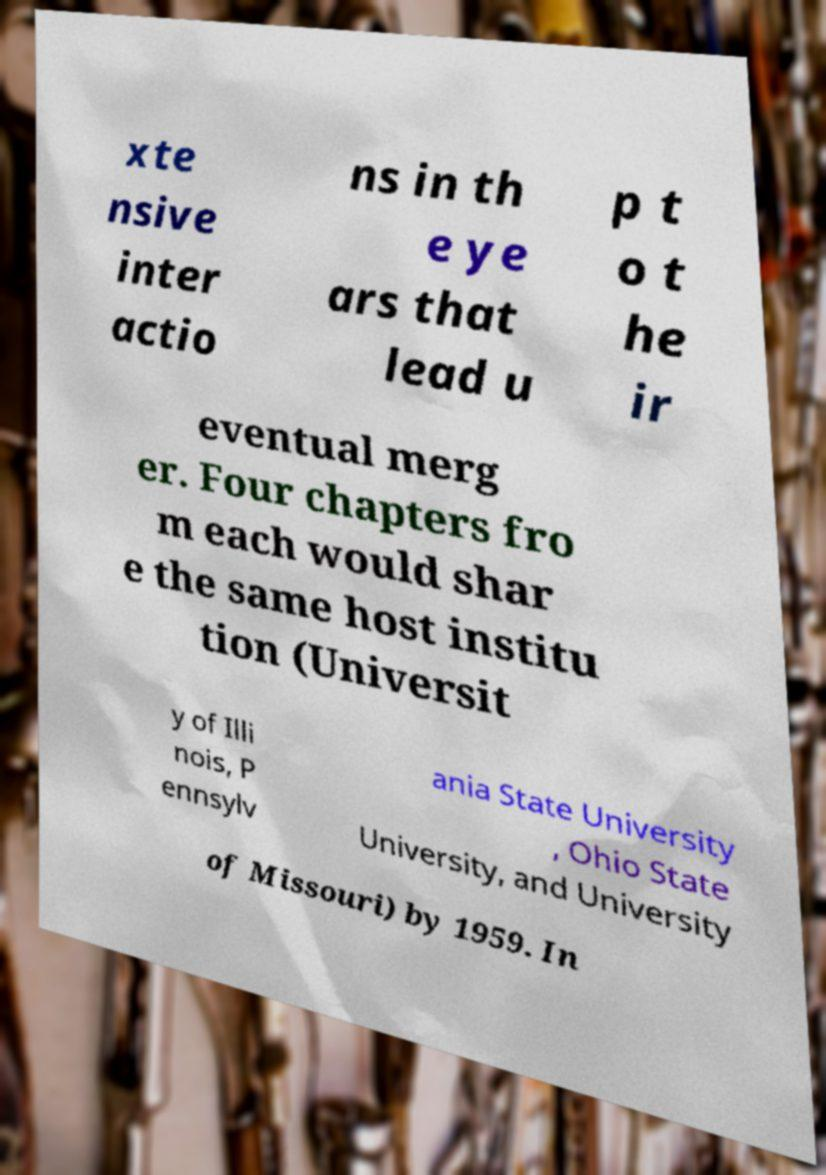For documentation purposes, I need the text within this image transcribed. Could you provide that? xte nsive inter actio ns in th e ye ars that lead u p t o t he ir eventual merg er. Four chapters fro m each would shar e the same host institu tion (Universit y of Illi nois, P ennsylv ania State University , Ohio State University, and University of Missouri) by 1959. In 